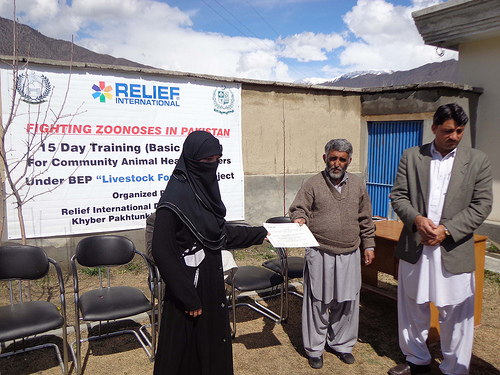<image>
Is the man to the left of the man? Yes. From this viewpoint, the man is positioned to the left side relative to the man. Where is the desk in relation to the man? Is it behind the man? Yes. From this viewpoint, the desk is positioned behind the man, with the man partially or fully occluding the desk. 